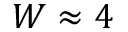<formula> <loc_0><loc_0><loc_500><loc_500>W \approx 4</formula> 